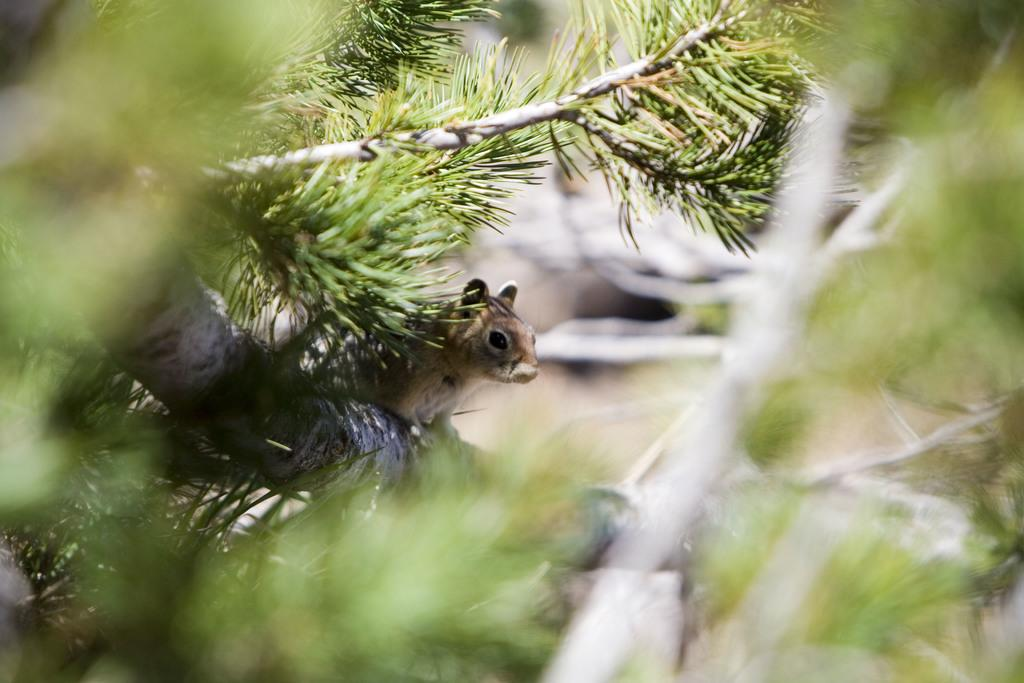What type of plant can be seen in the image? There is a tree with branches and leaves in the image. Are there any animals present in the image? Yes, a squirrel is present on the tree. Can you describe the background of the image? The background of the image is blurred. What type of soup is being prepared in the image? There is no soup present in the image; it features a tree with a squirrel and a blurred background. 